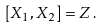<formula> <loc_0><loc_0><loc_500><loc_500>[ X _ { 1 } , X _ { 2 } ] = Z \, .</formula> 